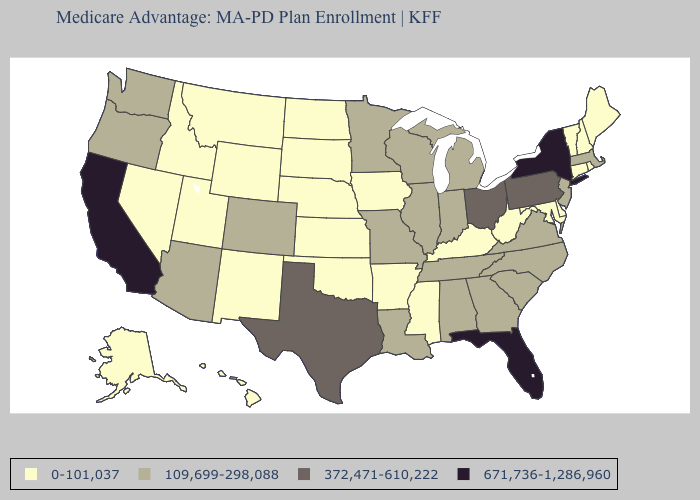Among the states that border Illinois , which have the lowest value?
Keep it brief. Iowa, Kentucky. Among the states that border Maryland , which have the lowest value?
Answer briefly. Delaware, West Virginia. Which states have the highest value in the USA?
Concise answer only. California, Florida, New York. What is the value of Idaho?
Short answer required. 0-101,037. What is the highest value in states that border Oklahoma?
Quick response, please. 372,471-610,222. Name the states that have a value in the range 0-101,037?
Answer briefly. Alaska, Arkansas, Connecticut, Delaware, Hawaii, Iowa, Idaho, Kansas, Kentucky, Maryland, Maine, Mississippi, Montana, North Dakota, Nebraska, New Hampshire, New Mexico, Nevada, Oklahoma, Rhode Island, South Dakota, Utah, Vermont, West Virginia, Wyoming. Name the states that have a value in the range 109,699-298,088?
Be succinct. Alabama, Arizona, Colorado, Georgia, Illinois, Indiana, Louisiana, Massachusetts, Michigan, Minnesota, Missouri, North Carolina, New Jersey, Oregon, South Carolina, Tennessee, Virginia, Washington, Wisconsin. What is the value of Vermont?
Give a very brief answer. 0-101,037. Is the legend a continuous bar?
Write a very short answer. No. What is the value of Connecticut?
Keep it brief. 0-101,037. Does Iowa have the same value as Vermont?
Answer briefly. Yes. Name the states that have a value in the range 109,699-298,088?
Answer briefly. Alabama, Arizona, Colorado, Georgia, Illinois, Indiana, Louisiana, Massachusetts, Michigan, Minnesota, Missouri, North Carolina, New Jersey, Oregon, South Carolina, Tennessee, Virginia, Washington, Wisconsin. Does the first symbol in the legend represent the smallest category?
Quick response, please. Yes. Does the map have missing data?
Keep it brief. No. Does the first symbol in the legend represent the smallest category?
Quick response, please. Yes. 